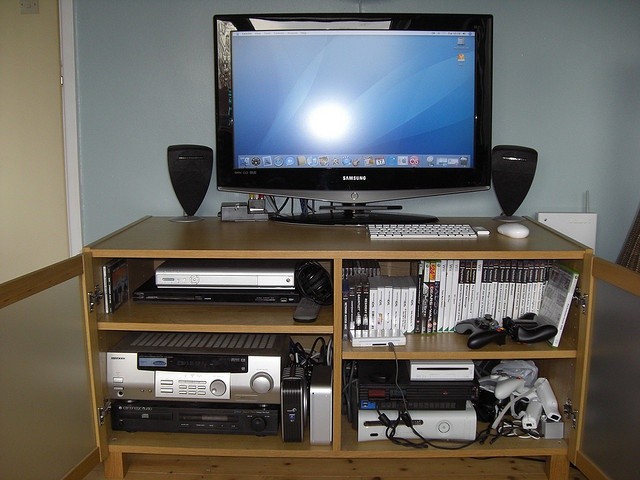Describe the objects in this image and their specific colors. I can see tv in gray, black, lightblue, and blue tones, book in gray, darkgray, black, and lightgray tones, keyboard in gray, darkgray, lightgray, and black tones, remote in gray, black, darkgray, and maroon tones, and remote in gray and black tones in this image. 